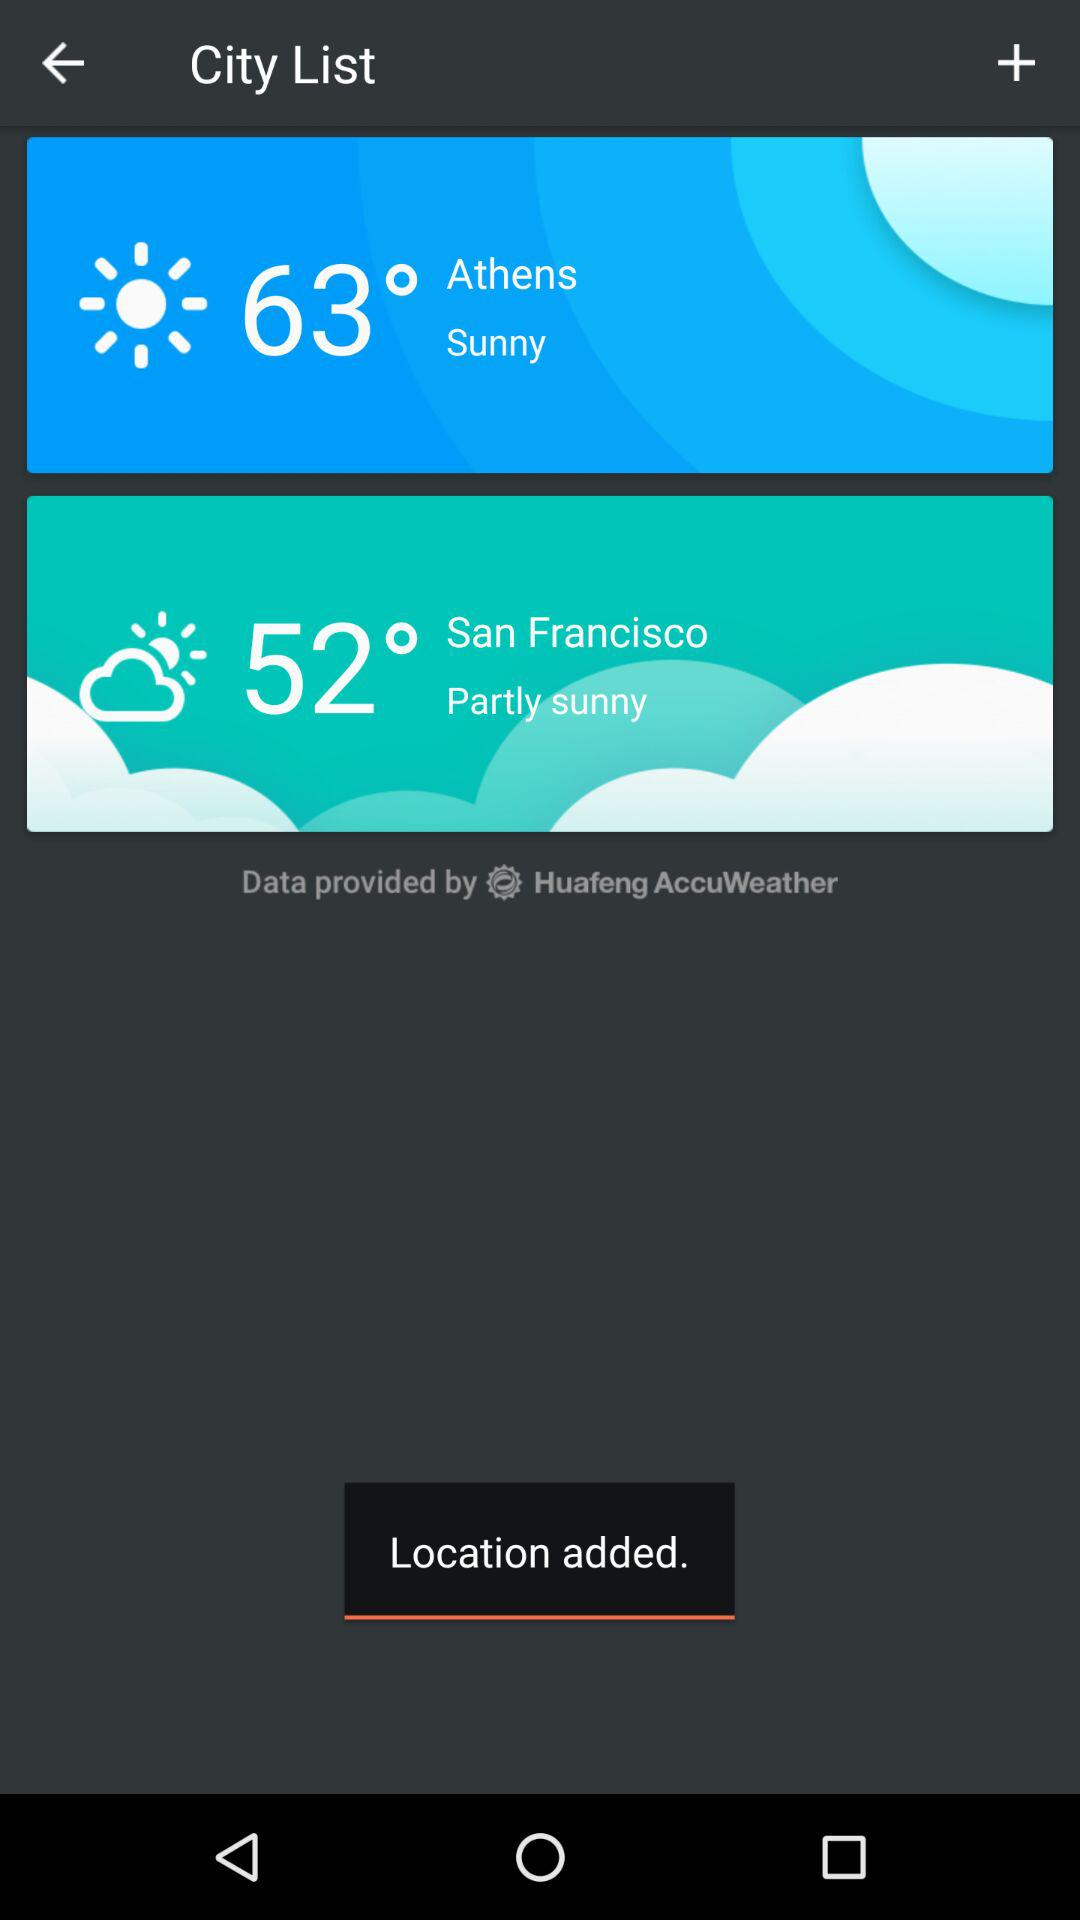What temperature is shown in Athens? The temperature shown in Athens is 63 degrees. 